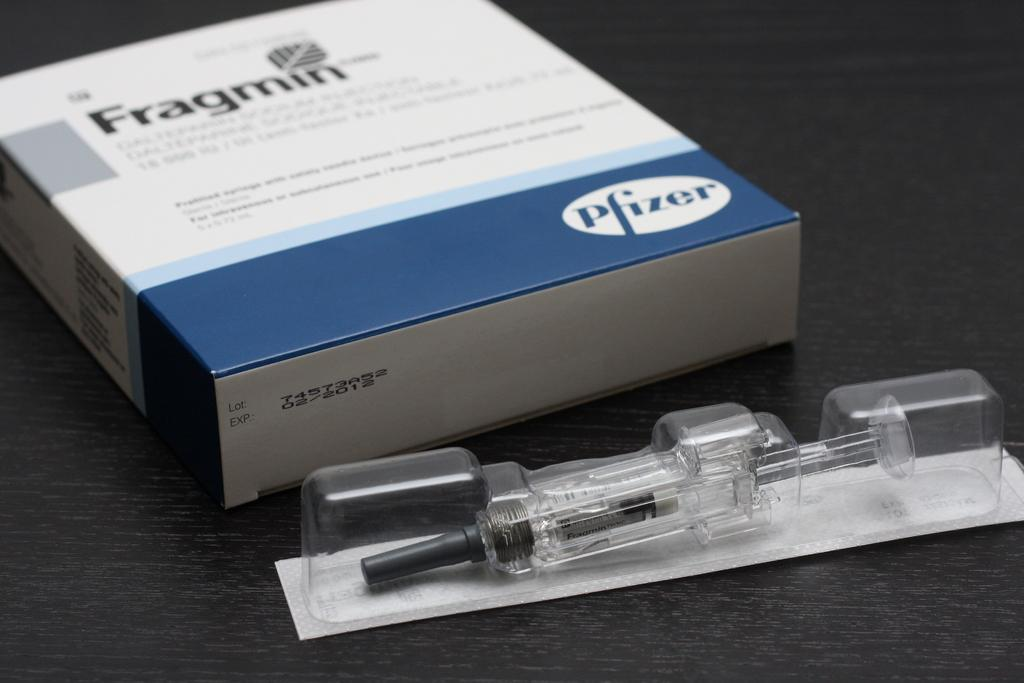Provide a one-sentence caption for the provided image. A Fragmin box with the label Pfizer on the bottom and a plastic container. 